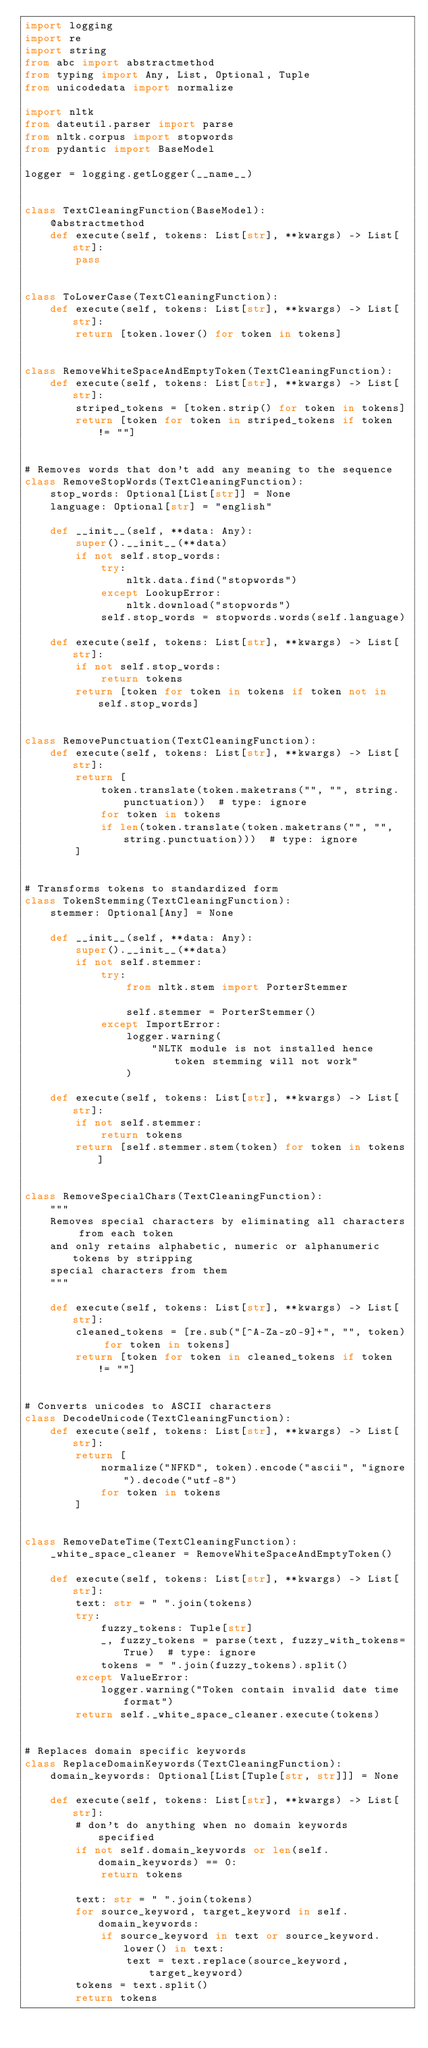Convert code to text. <code><loc_0><loc_0><loc_500><loc_500><_Python_>import logging
import re
import string
from abc import abstractmethod
from typing import Any, List, Optional, Tuple
from unicodedata import normalize

import nltk
from dateutil.parser import parse
from nltk.corpus import stopwords
from pydantic import BaseModel

logger = logging.getLogger(__name__)


class TextCleaningFunction(BaseModel):
    @abstractmethod
    def execute(self, tokens: List[str], **kwargs) -> List[str]:
        pass


class ToLowerCase(TextCleaningFunction):
    def execute(self, tokens: List[str], **kwargs) -> List[str]:
        return [token.lower() for token in tokens]


class RemoveWhiteSpaceAndEmptyToken(TextCleaningFunction):
    def execute(self, tokens: List[str], **kwargs) -> List[str]:
        striped_tokens = [token.strip() for token in tokens]
        return [token for token in striped_tokens if token != ""]


# Removes words that don't add any meaning to the sequence
class RemoveStopWords(TextCleaningFunction):
    stop_words: Optional[List[str]] = None
    language: Optional[str] = "english"

    def __init__(self, **data: Any):
        super().__init__(**data)
        if not self.stop_words:
            try:
                nltk.data.find("stopwords")
            except LookupError:
                nltk.download("stopwords")
            self.stop_words = stopwords.words(self.language)

    def execute(self, tokens: List[str], **kwargs) -> List[str]:
        if not self.stop_words:
            return tokens
        return [token for token in tokens if token not in self.stop_words]


class RemovePunctuation(TextCleaningFunction):
    def execute(self, tokens: List[str], **kwargs) -> List[str]:
        return [
            token.translate(token.maketrans("", "", string.punctuation))  # type: ignore
            for token in tokens
            if len(token.translate(token.maketrans("", "", string.punctuation)))  # type: ignore
        ]


# Transforms tokens to standardized form
class TokenStemming(TextCleaningFunction):
    stemmer: Optional[Any] = None

    def __init__(self, **data: Any):
        super().__init__(**data)
        if not self.stemmer:
            try:
                from nltk.stem import PorterStemmer

                self.stemmer = PorterStemmer()
            except ImportError:
                logger.warning(
                    "NLTK module is not installed hence token stemming will not work"
                )

    def execute(self, tokens: List[str], **kwargs) -> List[str]:
        if not self.stemmer:
            return tokens
        return [self.stemmer.stem(token) for token in tokens]


class RemoveSpecialChars(TextCleaningFunction):
    """
    Removes special characters by eliminating all characters from each token
    and only retains alphabetic, numeric or alphanumeric tokens by stripping
    special characters from them
    """

    def execute(self, tokens: List[str], **kwargs) -> List[str]:
        cleaned_tokens = [re.sub("[^A-Za-z0-9]+", "", token) for token in tokens]
        return [token for token in cleaned_tokens if token != ""]


# Converts unicodes to ASCII characters
class DecodeUnicode(TextCleaningFunction):
    def execute(self, tokens: List[str], **kwargs) -> List[str]:
        return [
            normalize("NFKD", token).encode("ascii", "ignore").decode("utf-8")
            for token in tokens
        ]


class RemoveDateTime(TextCleaningFunction):
    _white_space_cleaner = RemoveWhiteSpaceAndEmptyToken()

    def execute(self, tokens: List[str], **kwargs) -> List[str]:
        text: str = " ".join(tokens)
        try:
            fuzzy_tokens: Tuple[str]
            _, fuzzy_tokens = parse(text, fuzzy_with_tokens=True)  # type: ignore
            tokens = " ".join(fuzzy_tokens).split()
        except ValueError:
            logger.warning("Token contain invalid date time format")
        return self._white_space_cleaner.execute(tokens)


# Replaces domain specific keywords
class ReplaceDomainKeywords(TextCleaningFunction):
    domain_keywords: Optional[List[Tuple[str, str]]] = None

    def execute(self, tokens: List[str], **kwargs) -> List[str]:
        # don't do anything when no domain keywords specified
        if not self.domain_keywords or len(self.domain_keywords) == 0:
            return tokens

        text: str = " ".join(tokens)
        for source_keyword, target_keyword in self.domain_keywords:
            if source_keyword in text or source_keyword.lower() in text:
                text = text.replace(source_keyword, target_keyword)
        tokens = text.split()
        return tokens
</code> 